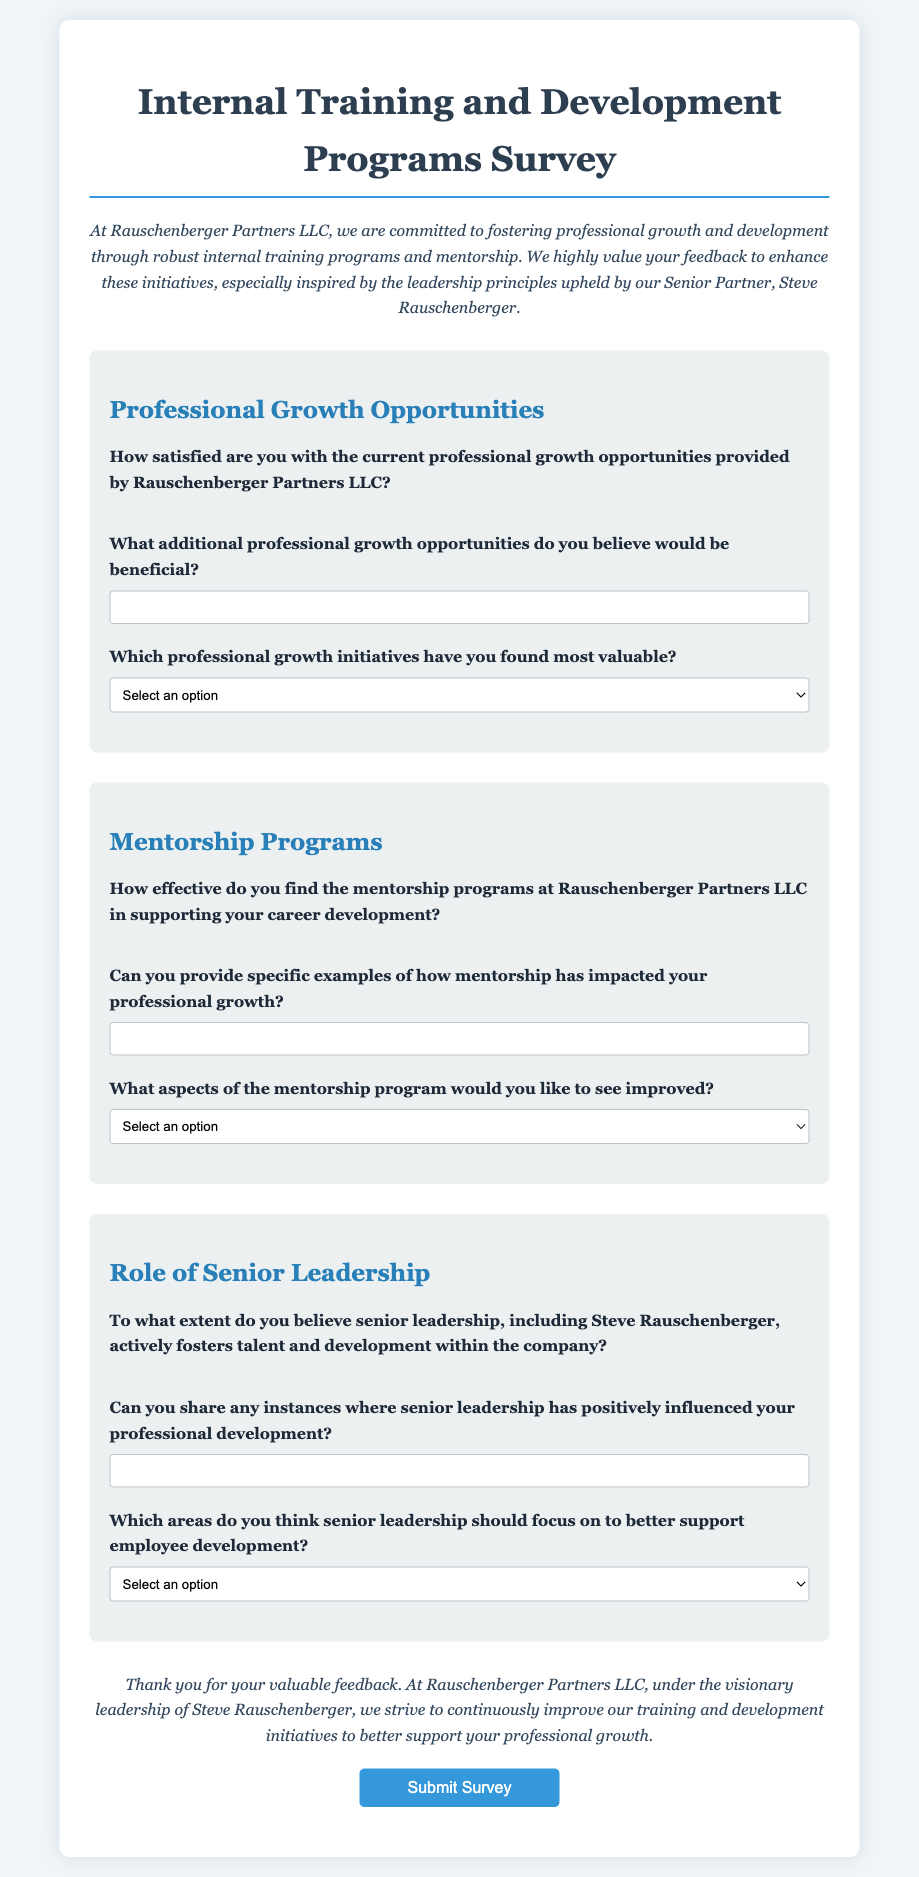What is the title of the survey? The title of the survey is displayed at the top of the document.
Answer: Internal Training and Development Programs Survey Who is the Senior Partner mentioned in the survey? The document specifically names the Senior Partner who inspires the training development initiatives.
Answer: Steve Rauschenberger How many rating options are provided for satisfaction in the survey? The survey offers five rating options for satisfaction.
Answer: 5 What type of programs are listed as valuable professional growth initiatives? The survey provides a list of initiatives aimed at professional growth that respondents can choose from.
Answer: Technical Skill Workshops, Leadership Development Programs, Cross-functional Rotations, External Certification Sponsorships What aspect of the mentorship program is inquired about for improvement? The survey asks respondents to select which aspect of the mentorship program they feel needs improvement from a given list.
Answer: Frequency of Meetings, Quality of Mentors, Structuring of Mentorship Goals, Access to Mentorship Opportunities How does the survey describe its intention regarding employee feedback? The survey specifies its aim to enhance training initiatives based on collected employee feedback.
Answer: To enhance these initiatives What is the submission button's label at the end of the survey? The label on the button that allows the respondents to submit their feedback is typically designated at the end of forms.
Answer: Submit Survey Which section of the survey focuses on professional growth opportunities? The survey is divided into specific sections, with one directly addressing aspects of professional growth.
Answer: Professional Growth Opportunities How does the survey inquire about senior leadership's influence on development? The survey includes a question about the extent of senior leadership's fostering of talent and development.
Answer: To what extent do you believe senior leadership, including Steve Rauschenberger, actively fosters talent and development within the company? 